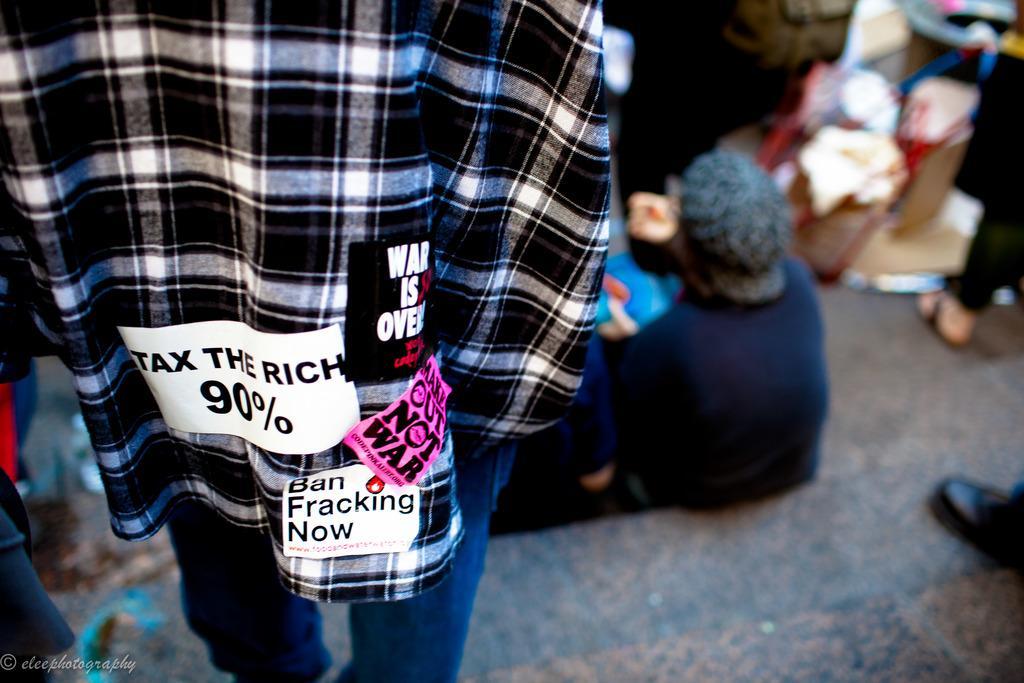Can you describe this image briefly? This picture describes about group of people, few are seated and few are standing, at the left bottom of the image we can see a watermark. 